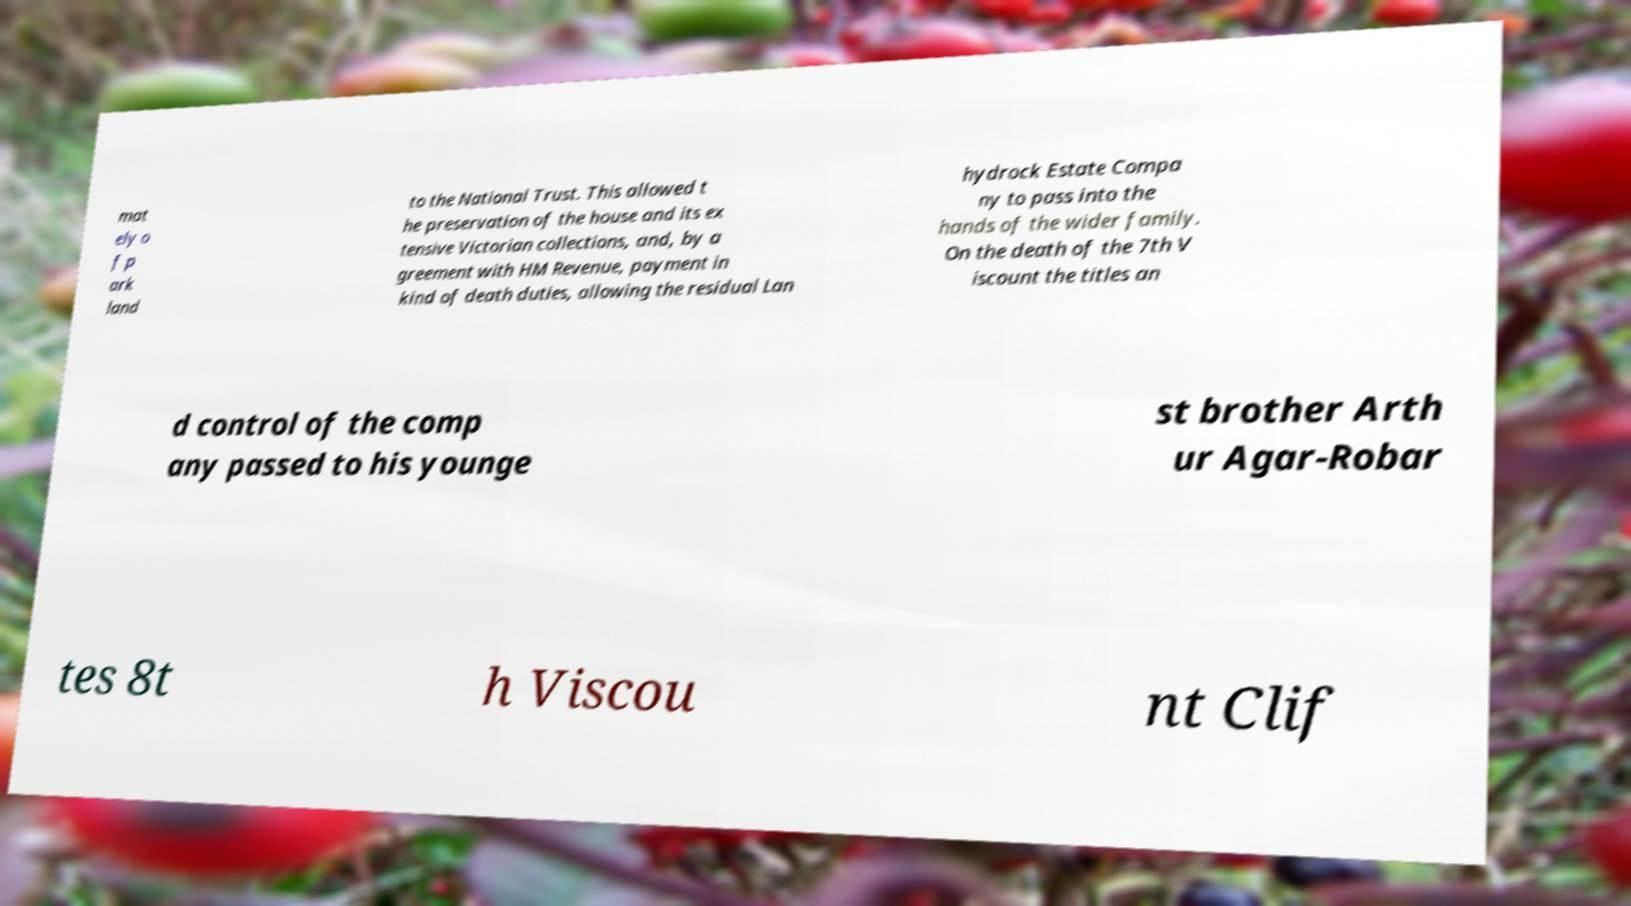There's text embedded in this image that I need extracted. Can you transcribe it verbatim? mat ely o f p ark land to the National Trust. This allowed t he preservation of the house and its ex tensive Victorian collections, and, by a greement with HM Revenue, payment in kind of death duties, allowing the residual Lan hydrock Estate Compa ny to pass into the hands of the wider family. On the death of the 7th V iscount the titles an d control of the comp any passed to his younge st brother Arth ur Agar-Robar tes 8t h Viscou nt Clif 